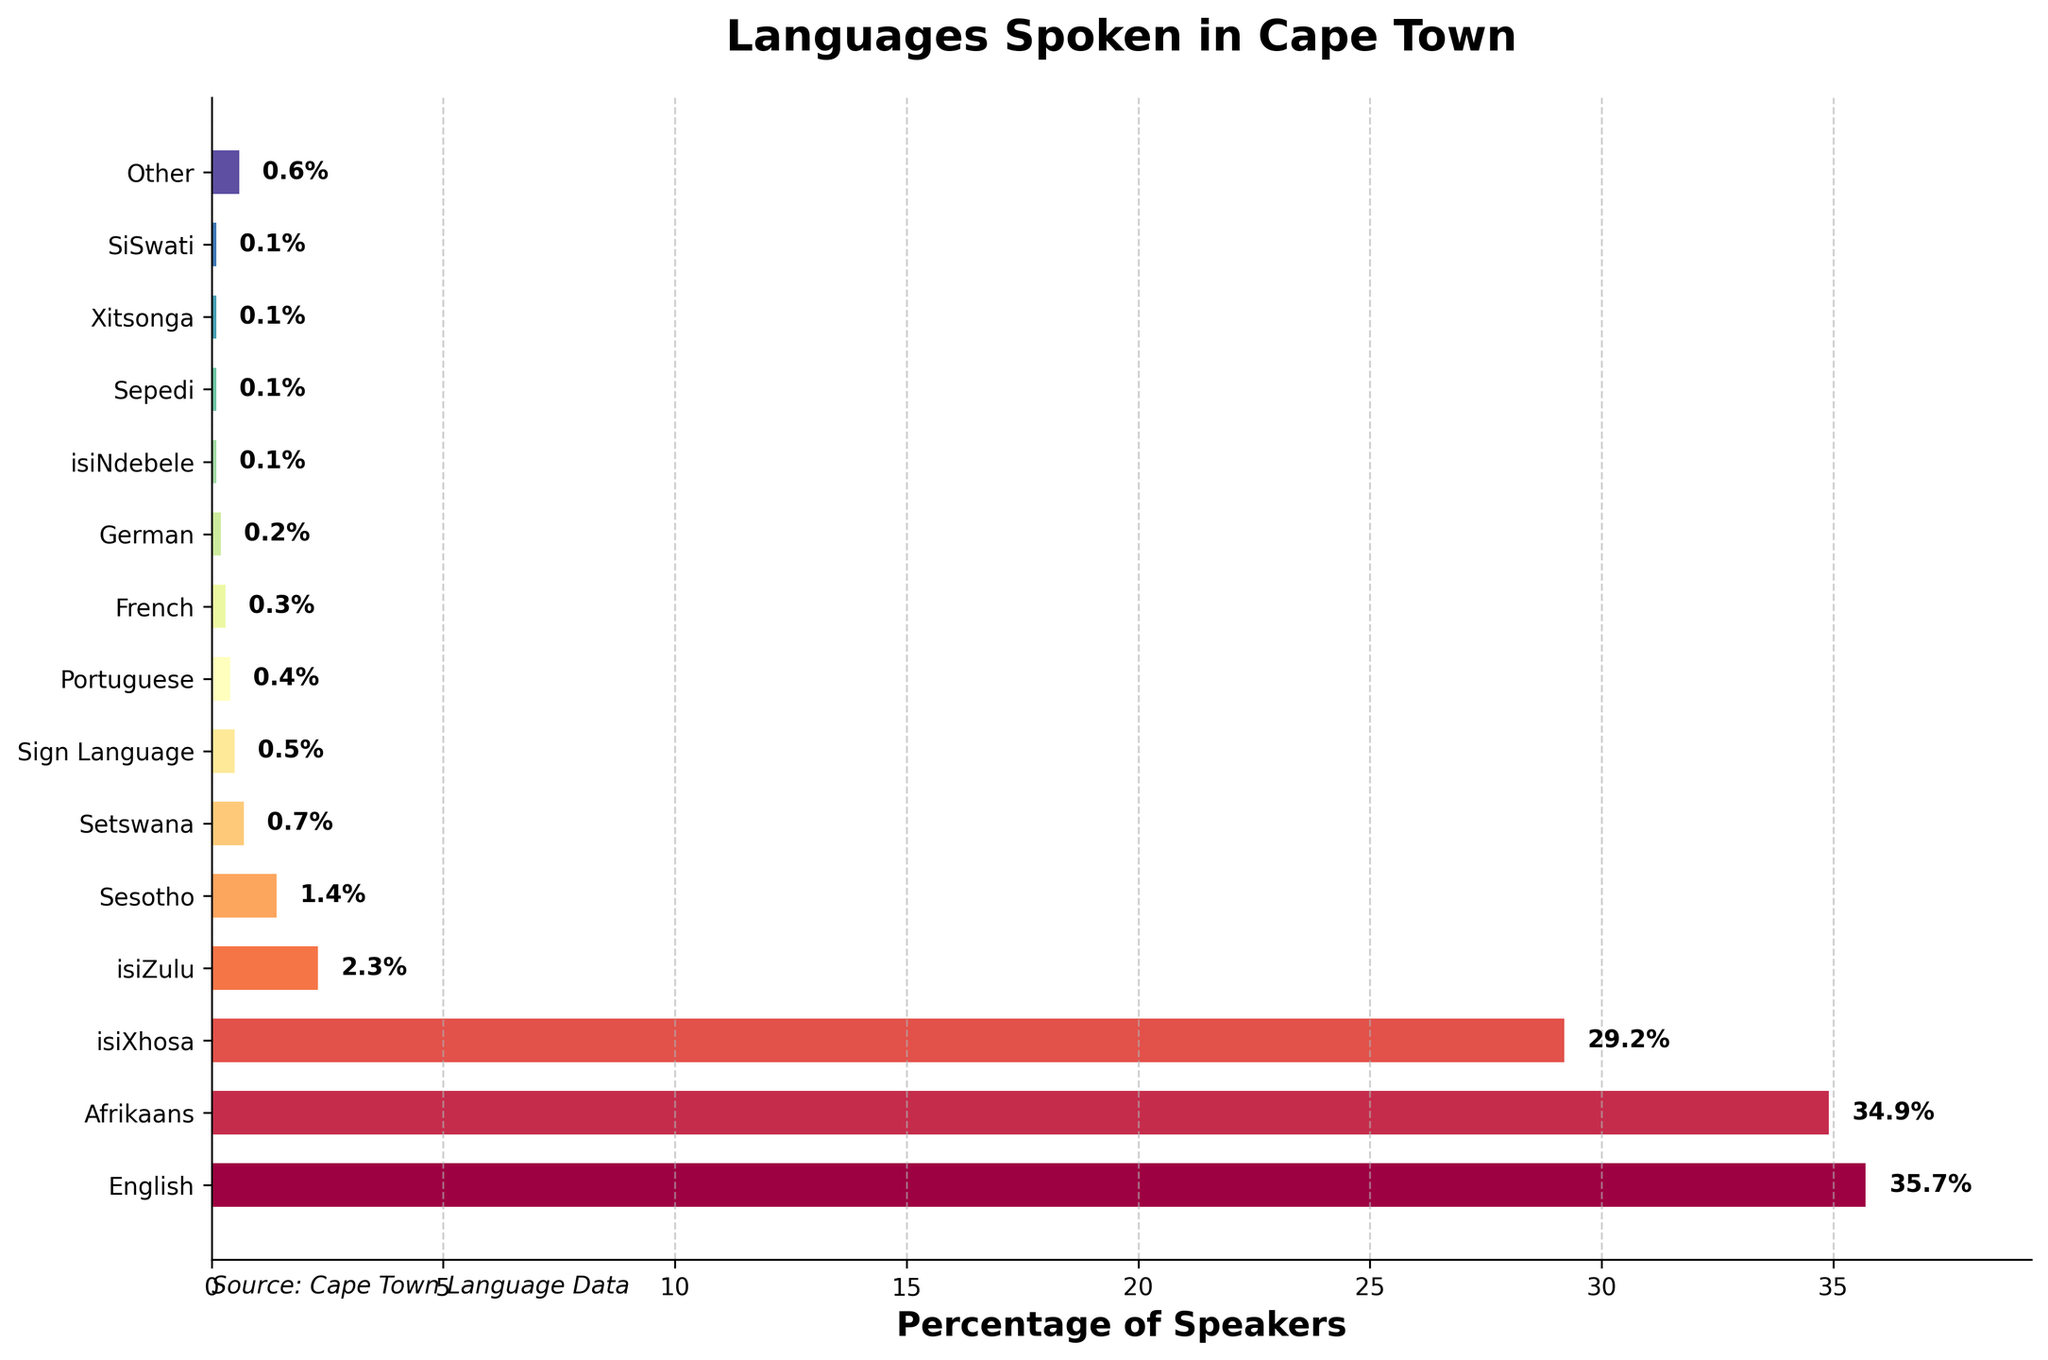What's the most spoken language in Cape Town? By glancing at the bar chart, the longest bar represents the most spoken language. English has the longest bar.
Answer: English Which two languages have virtually equal percentages of speakers? Look at the bars that have close lengths. English and Afrikaans have similar percentages, 35.7% and 34.9% respectively.
Answer: English and Afrikaans How much higher is the percentage of isiXhosa speakers compared to isiZulu speakers? Subtract the percentage of isiZulu from isiXhosa: 29.2% - 2.3% = 26.9%.
Answer: 26.9% What is the combined percentage of speakers for English, Afrikaans, and isiXhosa? Sum up the percentages: 35.7% + 34.9% + 29.2% = 99.8%.
Answer: 99.8% Which language has a slightly higher percentage of speakers, isiZulu or Sesotho? Compare the lengths of the bars for isiZulu and Sesotho, where isiZulu has 2.3% and Sesotho has 1.4%.
Answer: isiZulu What percentage of the population speaks languages categorized as 'Other'? Look at the 'Other' bar in the chart which shows 0.6%.
Answer: 0.6% Identify the least spoken language(s) in Cape Town as represented in the chart. The smallest bars represent the least spoken languages, which include isiNdebele, Sepedi, Xitsonga, and SiSwati, all at 0.1%.
Answer: isiNdebele, Sepedi, Xitsonga, SiSwati What is the average percentage of speakers for all languages spoken in Cape Town? First, sum all the percentages (35.7 + 34.9 + 29.2 + 2.3 + 1.4 + 0.7 + 0.5 + 0.4 + 0.3 + 0.2 + 0.1 + 0.1 + 0.1 + 0.1 + 0.6 = 106.6), then divide by the number of languages (15). The average is 106.6 / 15 = 7.11%.
Answer: 7.11% Which language is represented by the bar colored in the middle of the color gradient used? Based on the order from the top, the middle language in the dataset is Sesotho, which is represented by the seventh bar.
Answer: Sesotho 